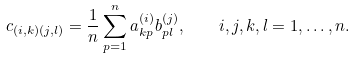<formula> <loc_0><loc_0><loc_500><loc_500>c _ { ( i , k ) ( j , l ) } = \frac { 1 } { n } \sum _ { p = 1 } ^ { n } a ^ { ( i ) } _ { k p } b _ { p l } ^ { ( j ) } , \quad i , j , k , l = 1 , \dots , n .</formula> 